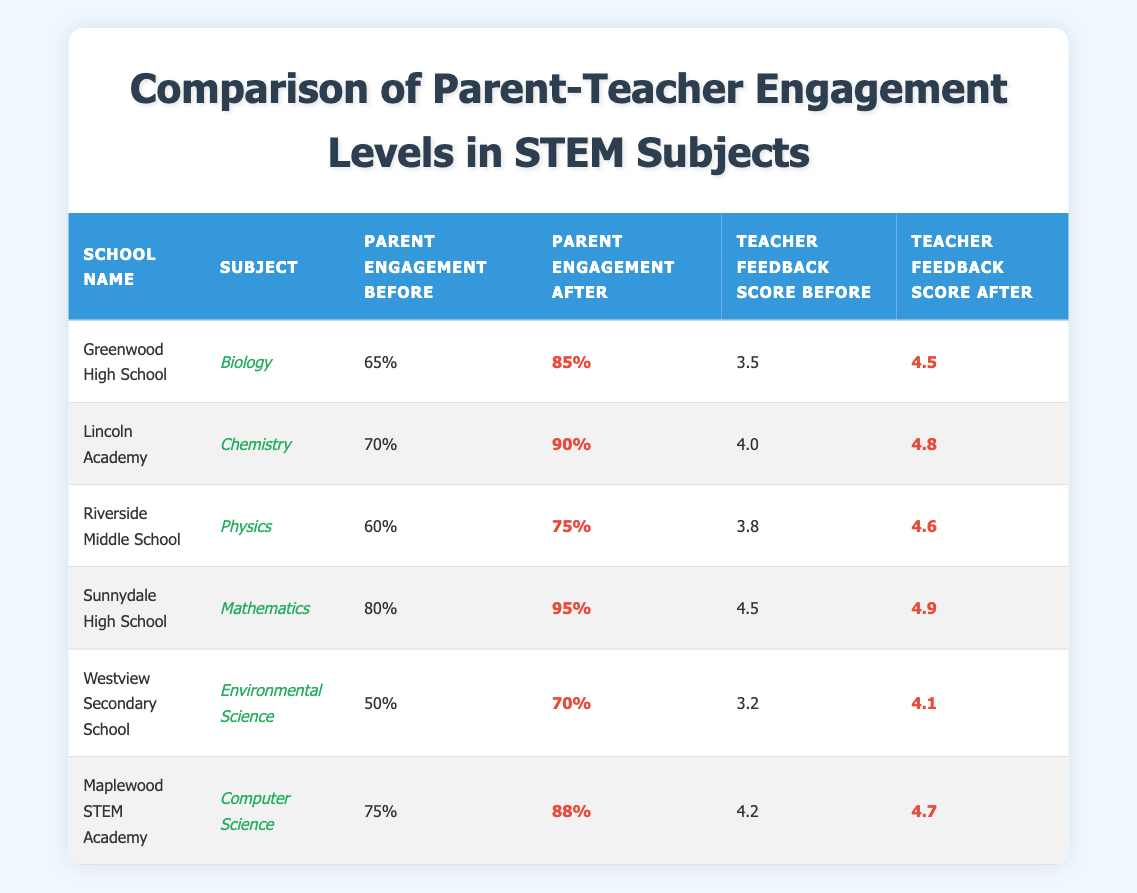What is the parent engagement percentage for Lincoln Academy in Chemistry before the intervention? According to the table, the parent engagement percentage for Lincoln Academy in Chemistry before the intervention is listed as 70%.
Answer: 70% What is the improvement in parent engagement after the intervention for Sunnydale High School? The parent engagement before the intervention was 80%, and after the intervention, it was 95%. The difference (improvement) is 95% - 80% = 15%.
Answer: 15% Which school had the highest parent engagement score after the intervention? Looking through the table, Sunnydale High School shows a parent engagement score of 95% after the intervention, which is the highest compared to other schools.
Answer: Sunnydale High School What was the teacher feedback score for Riverside Middle School before the intervention? The table indicates that Riverside Middle School had a teacher feedback score of 3.8 before the intervention.
Answer: 3.8 What is the average parent engagement percentage before the intervention across all schools? To find the average, sum all the parent engagement percentages before the intervention: (65 + 70 + 60 + 80 + 50 + 75) = 400. There are 6 schools, so the average is 400 / 6 = 66.67%.
Answer: 66.67% Is it true that the teacher feedback score for Environmental Science increased by more than 0.5 points after the intervention? Before the intervention, the teacher feedback score was 3.2, and after it was 4.1. The increase is 4.1 - 3.2 = 0.9, which is indeed more than 0.5 points.
Answer: Yes Which subject had the lowest parent engagement percentage after the intervention? Upon examining the table, Westview Secondary School's Environmental Science had a parent engagement percentage of 70% after the intervention, which is the lowest.
Answer: Environmental Science What is the total increase in teacher feedback scores across all subjects after the intervention? Total the teacher feedback scores after the intervention: (4.5 + 4.8 + 4.6 + 4.9 + 4.1 + 4.7) = 27.6. Before intervention, total was (3.5 + 4.0 + 3.8 + 4.5 + 3.2 + 4.2) = 23.2. The total increase is 27.6 - 23.2 = 4.4.
Answer: 4.4 Which school saw the smallest increase in parent engagement percentage after the intervention? Reviewing the increases: Greenwood High (20%), Lincoln Academy (20%), Riverside Middle (15%), Sunnydale High (15%), Westview Secondary (20%), and Maplewood STEM Academy (13%). The smallest increase is from Maplewood STEM Academy with 13%.
Answer: Maplewood STEM Academy How much higher was the teacher feedback score after the intervention for Chemistry compared to the score before the intervention? The teacher feedback score for Chemistry after the intervention is 4.8 and before it was 4.0. The increase is 4.8 - 4.0 = 0.8.
Answer: 0.8 